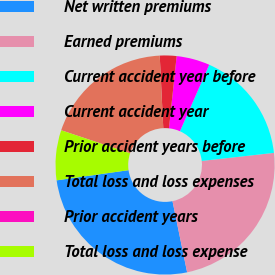Convert chart to OTSL. <chart><loc_0><loc_0><loc_500><loc_500><pie_chart><fcel>Net written premiums<fcel>Earned premiums<fcel>Current accident year before<fcel>Current accident year<fcel>Prior accident years before<fcel>Total loss and loss expenses<fcel>Prior accident years<fcel>Total loss and loss expense<nl><fcel>25.99%<fcel>23.54%<fcel>16.63%<fcel>4.92%<fcel>2.46%<fcel>19.08%<fcel>0.01%<fcel>7.37%<nl></chart> 